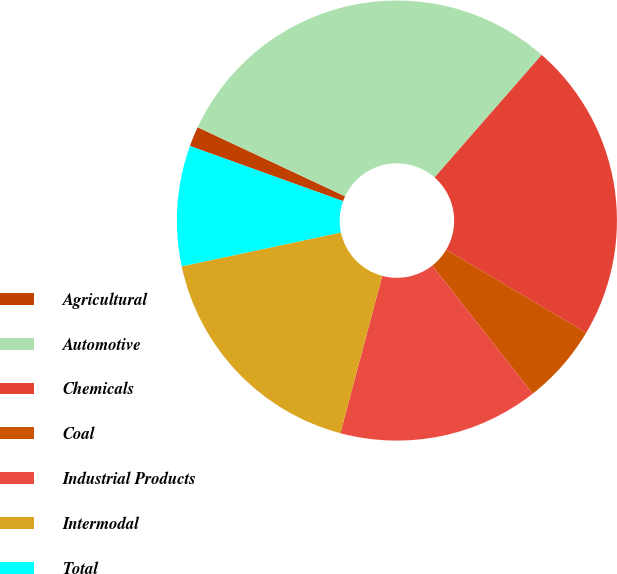<chart> <loc_0><loc_0><loc_500><loc_500><pie_chart><fcel>Agricultural<fcel>Automotive<fcel>Chemicals<fcel>Coal<fcel>Industrial Products<fcel>Intermodal<fcel>Total<nl><fcel>1.47%<fcel>29.46%<fcel>22.09%<fcel>5.89%<fcel>14.73%<fcel>17.53%<fcel>8.84%<nl></chart> 